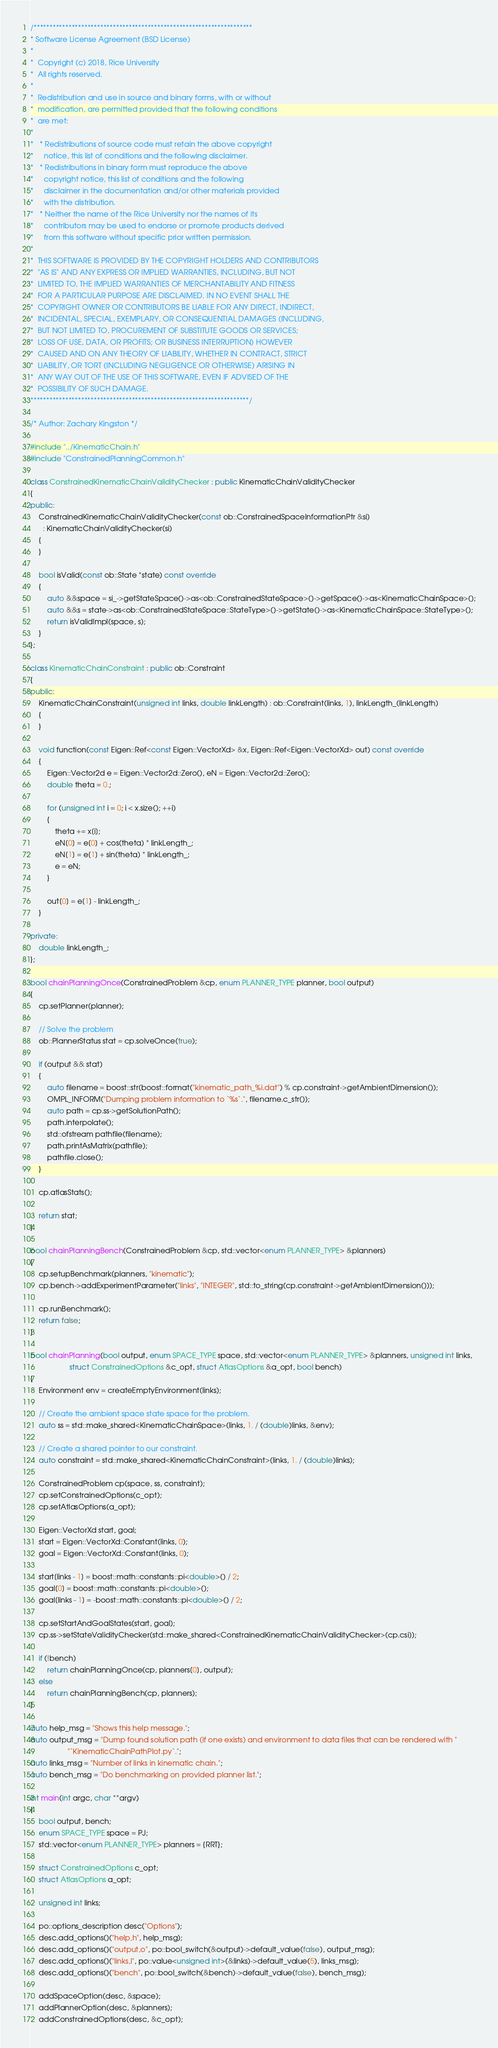Convert code to text. <code><loc_0><loc_0><loc_500><loc_500><_C++_>/*********************************************************************
* Software License Agreement (BSD License)
*
*  Copyright (c) 2018, Rice University
*  All rights reserved.
*
*  Redistribution and use in source and binary forms, with or without
*  modification, are permitted provided that the following conditions
*  are met:
*
*   * Redistributions of source code must retain the above copyright
*     notice, this list of conditions and the following disclaimer.
*   * Redistributions in binary form must reproduce the above
*     copyright notice, this list of conditions and the following
*     disclaimer in the documentation and/or other materials provided
*     with the distribution.
*   * Neither the name of the Rice University nor the names of its
*     contributors may be used to endorse or promote products derived
*     from this software without specific prior written permission.
*
*  THIS SOFTWARE IS PROVIDED BY THE COPYRIGHT HOLDERS AND CONTRIBUTORS
*  "AS IS" AND ANY EXPRESS OR IMPLIED WARRANTIES, INCLUDING, BUT NOT
*  LIMITED TO, THE IMPLIED WARRANTIES OF MERCHANTABILITY AND FITNESS
*  FOR A PARTICULAR PURPOSE ARE DISCLAIMED. IN NO EVENT SHALL THE
*  COPYRIGHT OWNER OR CONTRIBUTORS BE LIABLE FOR ANY DIRECT, INDIRECT,
*  INCIDENTAL, SPECIAL, EXEMPLARY, OR CONSEQUENTIAL DAMAGES (INCLUDING,
*  BUT NOT LIMITED TO, PROCUREMENT OF SUBSTITUTE GOODS OR SERVICES;
*  LOSS OF USE, DATA, OR PROFITS; OR BUSINESS INTERRUPTION) HOWEVER
*  CAUSED AND ON ANY THEORY OF LIABILITY, WHETHER IN CONTRACT, STRICT
*  LIABILITY, OR TORT (INCLUDING NEGLIGENCE OR OTHERWISE) ARISING IN
*  ANY WAY OUT OF THE USE OF THIS SOFTWARE, EVEN IF ADVISED OF THE
*  POSSIBILITY OF SUCH DAMAGE.
*********************************************************************/

/* Author: Zachary Kingston */

#include "../KinematicChain.h"
#include "ConstrainedPlanningCommon.h"

class ConstrainedKinematicChainValidityChecker : public KinematicChainValidityChecker
{
public:
    ConstrainedKinematicChainValidityChecker(const ob::ConstrainedSpaceInformationPtr &si)
      : KinematicChainValidityChecker(si)
    {
    }

    bool isValid(const ob::State *state) const override
    {
        auto &&space = si_->getStateSpace()->as<ob::ConstrainedStateSpace>()->getSpace()->as<KinematicChainSpace>();
        auto &&s = state->as<ob::ConstrainedStateSpace::StateType>()->getState()->as<KinematicChainSpace::StateType>();
        return isValidImpl(space, s);
    }
};

class KinematicChainConstraint : public ob::Constraint
{
public:
    KinematicChainConstraint(unsigned int links, double linkLength) : ob::Constraint(links, 1), linkLength_(linkLength)
    {
    }

    void function(const Eigen::Ref<const Eigen::VectorXd> &x, Eigen::Ref<Eigen::VectorXd> out) const override
    {
        Eigen::Vector2d e = Eigen::Vector2d::Zero(), eN = Eigen::Vector2d::Zero();
        double theta = 0.;

        for (unsigned int i = 0; i < x.size(); ++i)
        {
            theta += x[i];
            eN[0] = e[0] + cos(theta) * linkLength_;
            eN[1] = e[1] + sin(theta) * linkLength_;
            e = eN;
        }

        out[0] = e[1] - linkLength_;
    }

private:
    double linkLength_;
};

bool chainPlanningOnce(ConstrainedProblem &cp, enum PLANNER_TYPE planner, bool output)
{
    cp.setPlanner(planner);

    // Solve the problem
    ob::PlannerStatus stat = cp.solveOnce(true);

    if (output && stat)
    {
        auto filename = boost::str(boost::format("kinematic_path_%i.dat") % cp.constraint->getAmbientDimension());
        OMPL_INFORM("Dumping problem information to `%s`.", filename.c_str());
        auto path = cp.ss->getSolutionPath();
        path.interpolate();
        std::ofstream pathfile(filename);
        path.printAsMatrix(pathfile);
        pathfile.close();
    }

    cp.atlasStats();

    return stat;
}

bool chainPlanningBench(ConstrainedProblem &cp, std::vector<enum PLANNER_TYPE> &planners)
{
    cp.setupBenchmark(planners, "kinematic");
    cp.bench->addExperimentParameter("links", "INTEGER", std::to_string(cp.constraint->getAmbientDimension()));

    cp.runBenchmark();
    return false;
}

bool chainPlanning(bool output, enum SPACE_TYPE space, std::vector<enum PLANNER_TYPE> &planners, unsigned int links,
                   struct ConstrainedOptions &c_opt, struct AtlasOptions &a_opt, bool bench)
{
    Environment env = createEmptyEnvironment(links);

    // Create the ambient space state space for the problem.
    auto ss = std::make_shared<KinematicChainSpace>(links, 1. / (double)links, &env);

    // Create a shared pointer to our constraint.
    auto constraint = std::make_shared<KinematicChainConstraint>(links, 1. / (double)links);

    ConstrainedProblem cp(space, ss, constraint);
    cp.setConstrainedOptions(c_opt);
    cp.setAtlasOptions(a_opt);

    Eigen::VectorXd start, goal;
    start = Eigen::VectorXd::Constant(links, 0);
    goal = Eigen::VectorXd::Constant(links, 0);

    start[links - 1] = boost::math::constants::pi<double>() / 2;
    goal[0] = boost::math::constants::pi<double>();
    goal[links - 1] = -boost::math::constants::pi<double>() / 2;

    cp.setStartAndGoalStates(start, goal);
    cp.ss->setStateValidityChecker(std::make_shared<ConstrainedKinematicChainValidityChecker>(cp.csi));

    if (!bench)
        return chainPlanningOnce(cp, planners[0], output);
    else
        return chainPlanningBench(cp, planners);
}

auto help_msg = "Shows this help message.";
auto output_msg = "Dump found solution path (if one exists) and environment to data files that can be rendered with "
                  "`KinematicChainPathPlot.py`.";
auto links_msg = "Number of links in kinematic chain.";
auto bench_msg = "Do benchmarking on provided planner list.";

int main(int argc, char **argv)
{
    bool output, bench;
    enum SPACE_TYPE space = PJ;
    std::vector<enum PLANNER_TYPE> planners = {RRT};

    struct ConstrainedOptions c_opt;
    struct AtlasOptions a_opt;

    unsigned int links;

    po::options_description desc("Options");
    desc.add_options()("help,h", help_msg);
    desc.add_options()("output,o", po::bool_switch(&output)->default_value(false), output_msg);
    desc.add_options()("links,l", po::value<unsigned int>(&links)->default_value(5), links_msg);
    desc.add_options()("bench", po::bool_switch(&bench)->default_value(false), bench_msg);

    addSpaceOption(desc, &space);
    addPlannerOption(desc, &planners);
    addConstrainedOptions(desc, &c_opt);</code> 